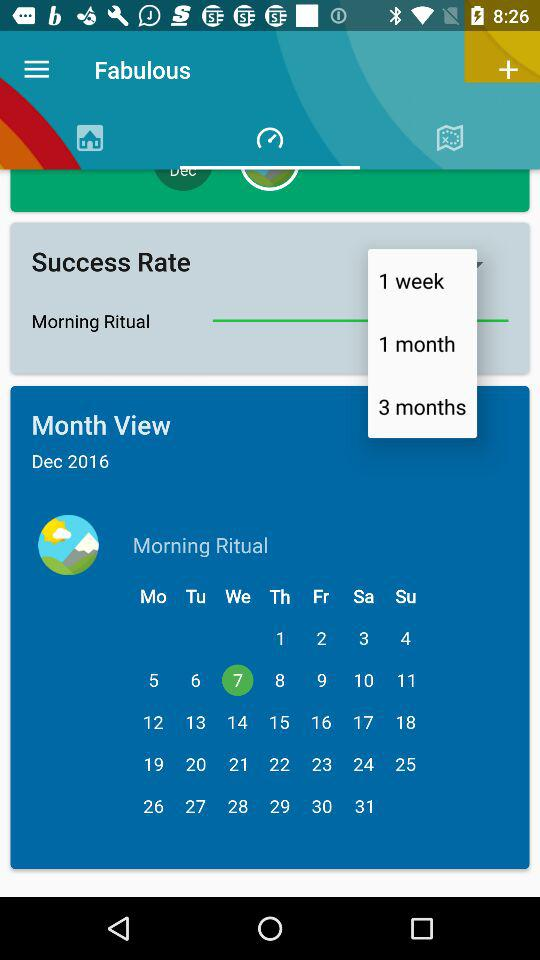What month and year are displayed in the month view? The displayed month and year are December and 2016, respectively. 